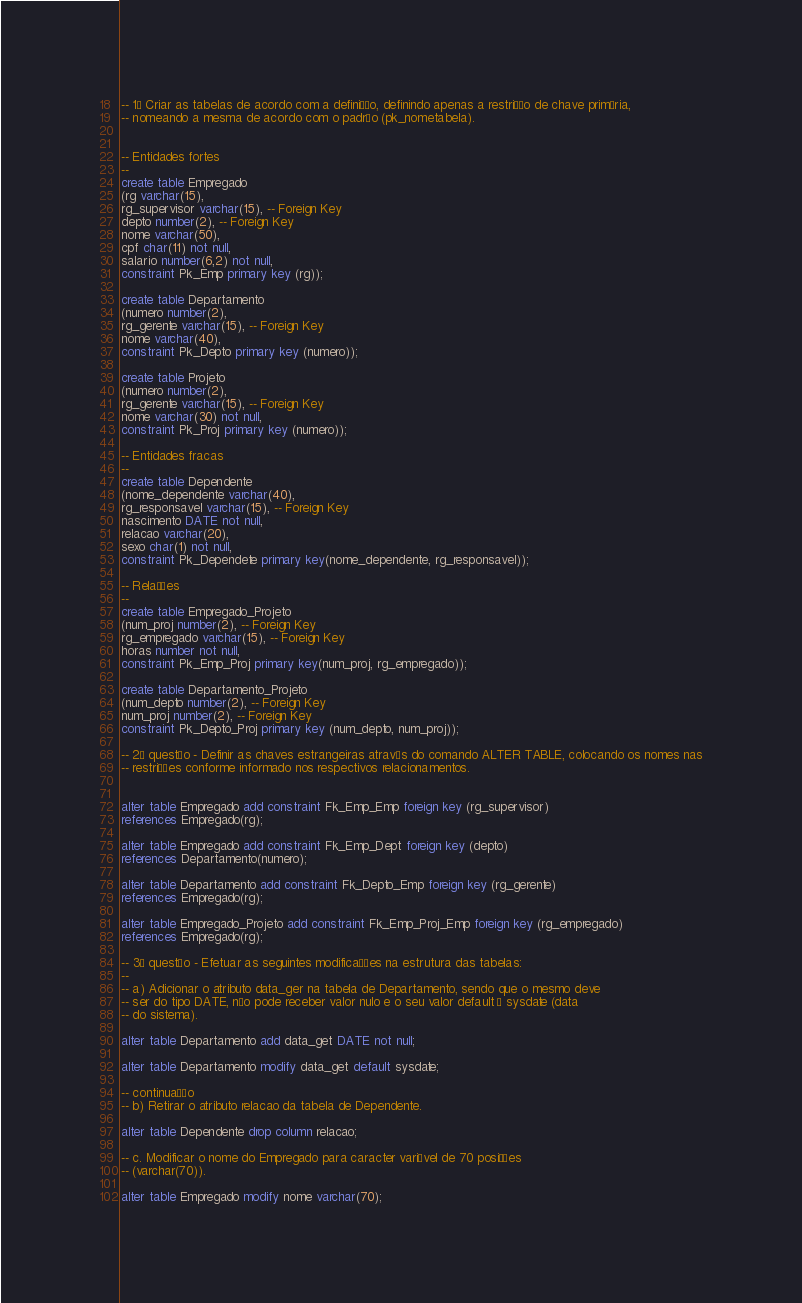Convert code to text. <code><loc_0><loc_0><loc_500><loc_500><_SQL_>-- 1ª Criar as tabelas de acordo com a definição, definindo apenas a restrição de chave primária,
-- nomeando a mesma de acordo com o padrão (pk_nometabela).


-- Entidades fortes
--
create table Empregado
(rg varchar(15),
rg_supervisor varchar(15), -- Foreign Key
depto number(2), -- Foreign Key
nome varchar(50),
cpf char(11) not null,
salario number(6,2) not null,
constraint Pk_Emp primary key (rg));

create table Departamento
(numero number(2),
rg_gerente varchar(15), -- Foreign Key
nome varchar(40),
constraint Pk_Depto primary key (numero));

create table Projeto
(numero number(2),
rg_gerente varchar(15), -- Foreign Key
nome varchar(30) not null,
constraint Pk_Proj primary key (numero));

-- Entidades fracas
--
create table Dependente
(nome_dependente varchar(40),
rg_responsavel varchar(15), -- Foreign Key
nascimento DATE not null,
relacao varchar(20),
sexo char(1) not null,
constraint Pk_Dependete primary key(nome_dependente, rg_responsavel));

-- Relações
--
create table Empregado_Projeto
(num_proj number(2), -- Foreign Key
rg_empregado varchar(15), -- Foreign Key
horas number not null,
constraint Pk_Emp_Proj primary key(num_proj, rg_empregado));

create table Departamento_Projeto
(num_depto number(2), -- Foreign Key
num_proj number(2), -- Foreign Key
constraint Pk_Depto_Proj primary key (num_depto, num_proj));

-- 2ª questão - Definir as chaves estrangeiras através do comando ALTER TABLE, colocando os nomes nas
-- restrições conforme informado nos respectivos relacionamentos.


alter table Empregado add constraint Fk_Emp_Emp foreign key (rg_supervisor) 
references Empregado(rg);

alter table Empregado add constraint Fk_Emp_Dept foreign key (depto) 
references Departamento(numero);

alter table Departamento add constraint Fk_Depto_Emp foreign key (rg_gerente) 
references Empregado(rg);

alter table Empregado_Projeto add constraint Fk_Emp_Proj_Emp foreign key (rg_empregado) 
references Empregado(rg);

-- 3ª questão - Efetuar as seguintes modificações na estrutura das tabelas: 
--
-- a) Adicionar o atributo data_ger na tabela de Departamento, sendo que o mesmo deve
-- ser do tipo DATE, não pode receber valor nulo e o seu valor default é sysdate (data
-- do sistema). 

alter table Departamento add data_get DATE not null;

alter table Departamento modify data_get default sysdate;

-- continuação
-- b) Retirar o atributo relacao da tabela de Dependente.

alter table Dependente drop column relacao;

-- c. Modificar o nome do Empregado para caracter variável de 70 posições
-- (varchar(70)).

alter table Empregado modify nome varchar(70);
</code> 